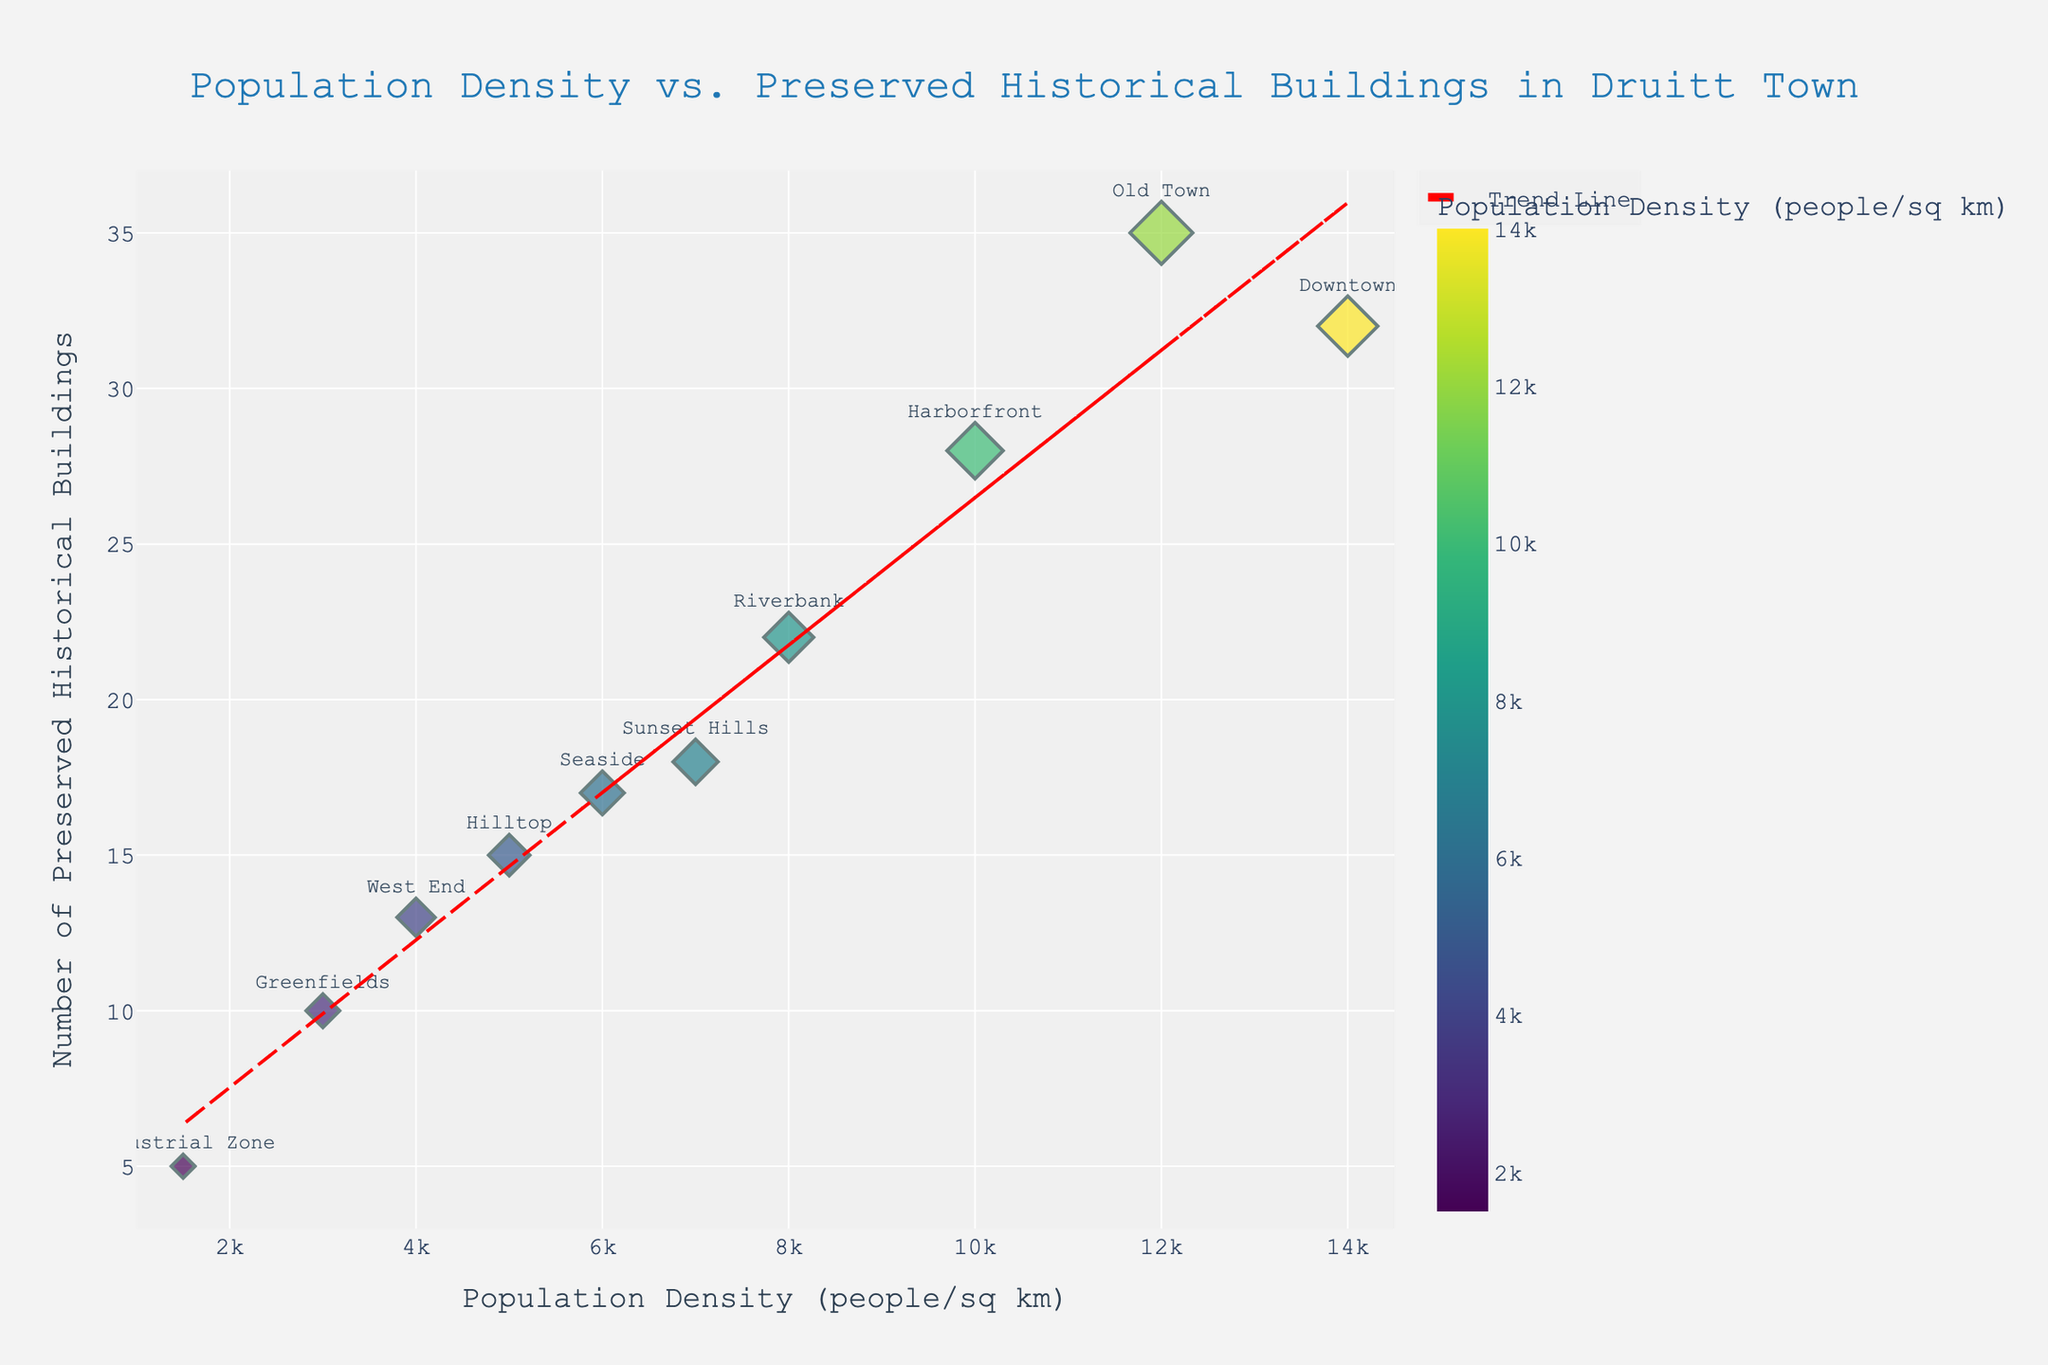What is the title of the figure? The title of the figure is located at the top and is usually written in a larger font to draw attention. In this case, by looking at the plot, you can see the title text centered at the top.
Answer: Population Density vs. Preserved Historical Buildings in Druitt Town Which district has the highest population density? To find the district with the highest population density, you need to look at the x-axis and identify the data point that is farthest to the right. The hover information can also help to find the specific district name.
Answer: Downtown How many historical buildings are preserved in Sunset Hills? Locate the data point labeled "Sunset Hills" by looking for the text near the scatter points, then check the y-axis to count the number associated with this district.
Answer: 18 What is the range of population densities shown in the plot? The range of the population densities can be determined by looking at the minimum and maximum values of the x-axis. Specifically, find the smallest and largest values indicated.
Answer: 1500 to 14000 Which district has more preserved historical buildings, Harborfront or Riverbank? Compare the y-axis (Number of Preserved Historical Buildings) values for the districts "Harborfront" and "Riverbank".
Answer: Harborfront What is the trend line indicating about the relationship between population density and the number of preserved historical buildings? The trend line is calculated from the scatter plot data, summarizing the overall direction that the data points tend to follow. By observing if it slopes upward or downward, one can infer the relationship.
Answer: Positive correlation What is the average number of preserved historical buildings in districts with population density higher than 5000 people/sq km? Identify districts where population density is greater than 5000 (Old Town, Riverbank, Harborfront, Sunset Hills, Downtown), sum their preserved buildings (35+22+28+18+32=135), and divide by the number of such districts (5).
Answer: 27 How many districts have fewer than 20 preserved historical buildings? Count the number of data points on the scatter plot that lie below the y-axis value of 20.
Answer: 5 Do any two districts have the same number of preserved historical buildings? Check to see if any two y-axis values (Number of Preserved Historical Buildings) are identical, and look at the corresponding data points.
Answer: No Which district has the lowest number of preserved historical buildings and what is its population density? Identify the data point at the lowest point on the y-axis, then read the population density value on the x-axis for this data point and check the label to find the district.
Answer: Industrial Zone, 1500 